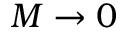<formula> <loc_0><loc_0><loc_500><loc_500>M \rightarrow 0</formula> 